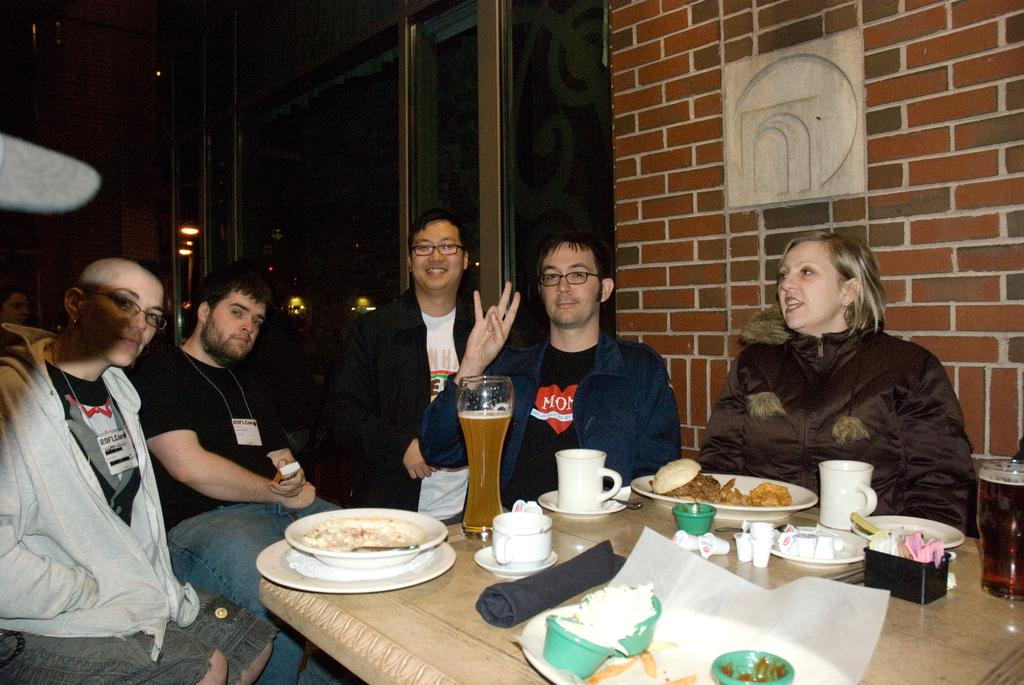What are the people in the image doing? The people in the image are sitting on chairs. What is on the table in the image? There are glasses, plates, and other objects on the table. Can you describe the wall in the image? There is a wall on the right side of the image. Where is the mailbox located in the image? There is no mailbox present in the image. What type of quiver is being used by the woman in the image? There is no woman or quiver present in the image. 